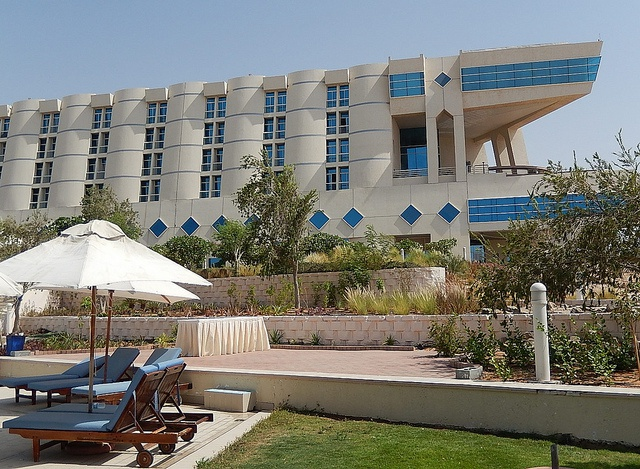Describe the objects in this image and their specific colors. I can see umbrella in darkgray, white, gray, and black tones, chair in darkgray, black, maroon, gray, and blue tones, umbrella in darkgray, white, tan, and maroon tones, chair in darkgray, black, gray, and maroon tones, and chair in darkgray, darkblue, black, gray, and navy tones in this image. 